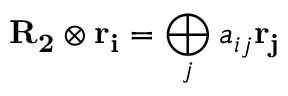<formula> <loc_0><loc_0><loc_500><loc_500>{ R _ { 2 } } \otimes { r _ { i } } = \bigoplus _ { j } a _ { i j } { r _ { j } }</formula> 